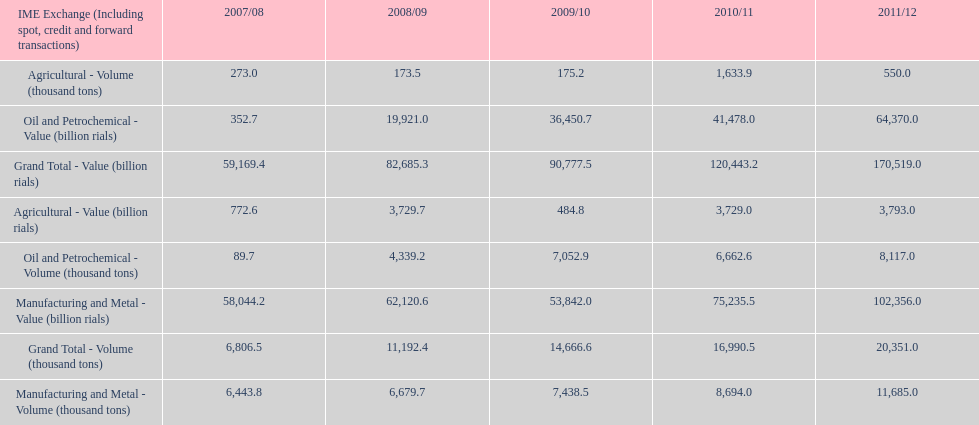Did 2010/11 or 2011/12 make more in grand total value? 2011/12. 